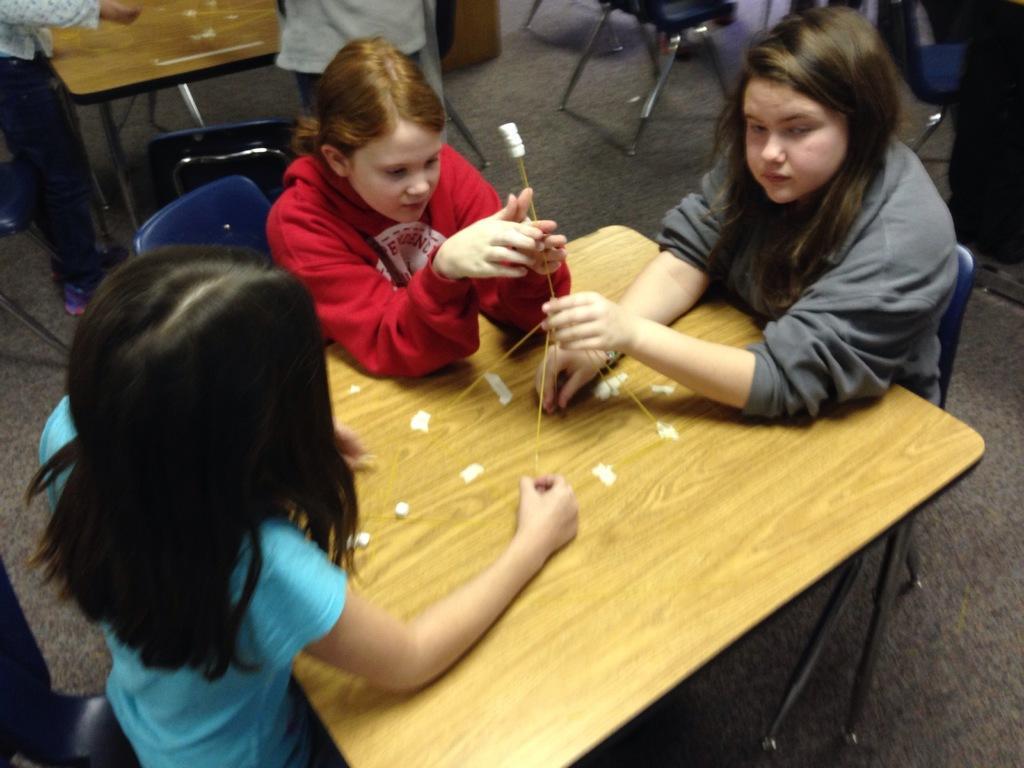Can you describe this image briefly? In this picture there are three who are sitting on the chair and holding a stick. There are few people. There is a table. 